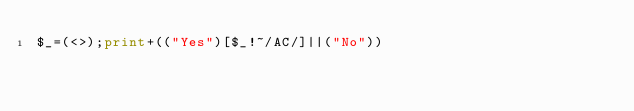<code> <loc_0><loc_0><loc_500><loc_500><_Perl_>$_=(<>);print+(("Yes")[$_!~/AC/]||("No"))</code> 